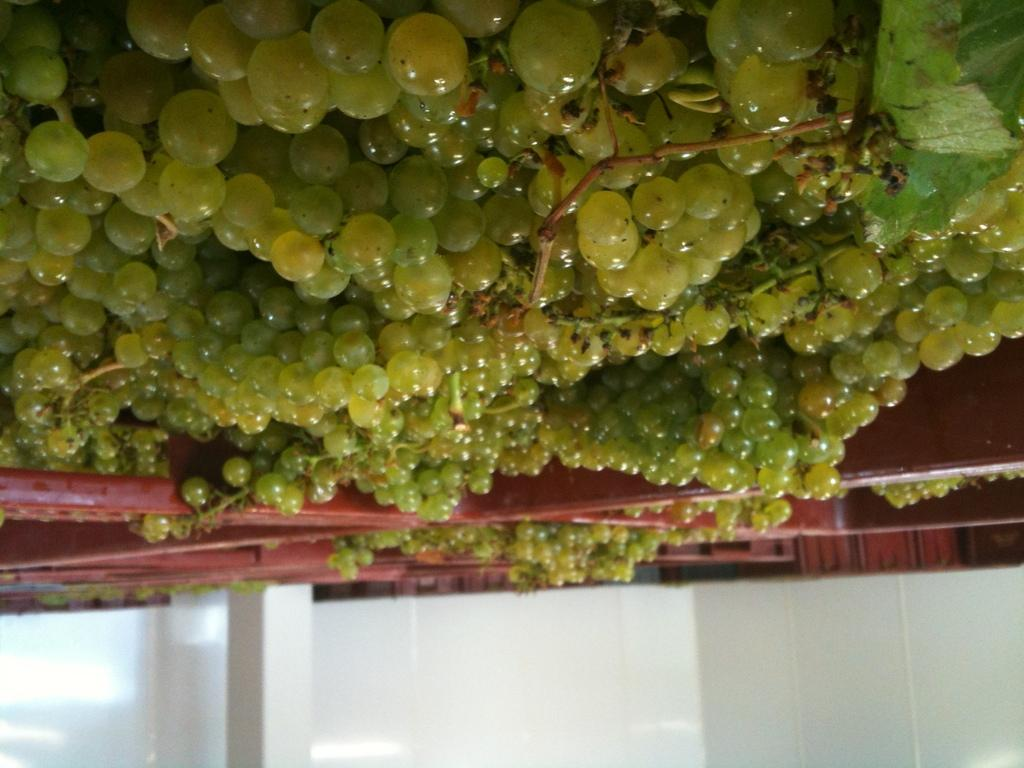What type of structure can be seen in the image? There is a wall in the image. Are there any other architectural features present? Yes, there is a pillar in the image. What can be seen in the background of the image? There is a group of grapes visible in the background of the image. What type of song can be heard playing in the background of the image? There is no song playing in the background of the image; it is a still image. What type of wool is used to make the pillar in the image? The pillar in the image is not made of wool; it is likely made of stone or concrete. 